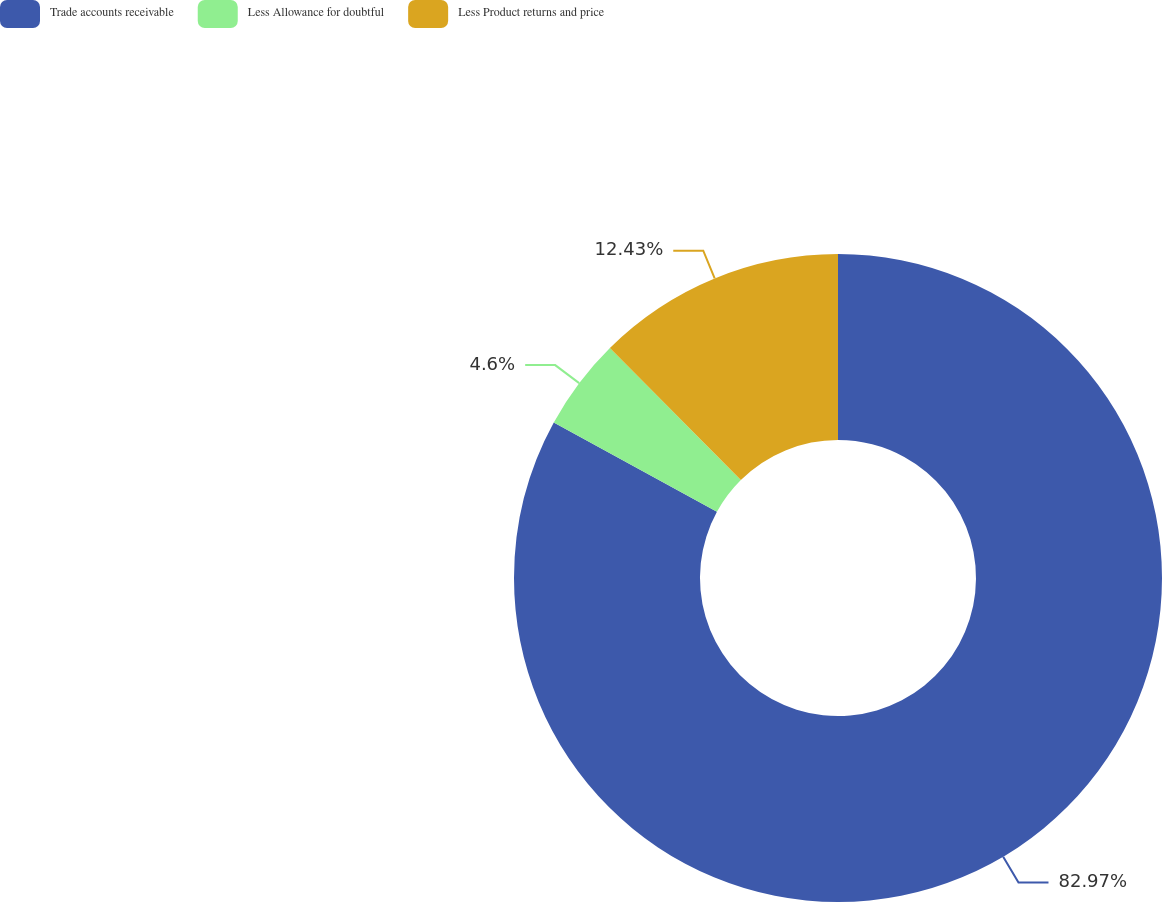Convert chart to OTSL. <chart><loc_0><loc_0><loc_500><loc_500><pie_chart><fcel>Trade accounts receivable<fcel>Less Allowance for doubtful<fcel>Less Product returns and price<nl><fcel>82.97%<fcel>4.6%<fcel>12.43%<nl></chart> 